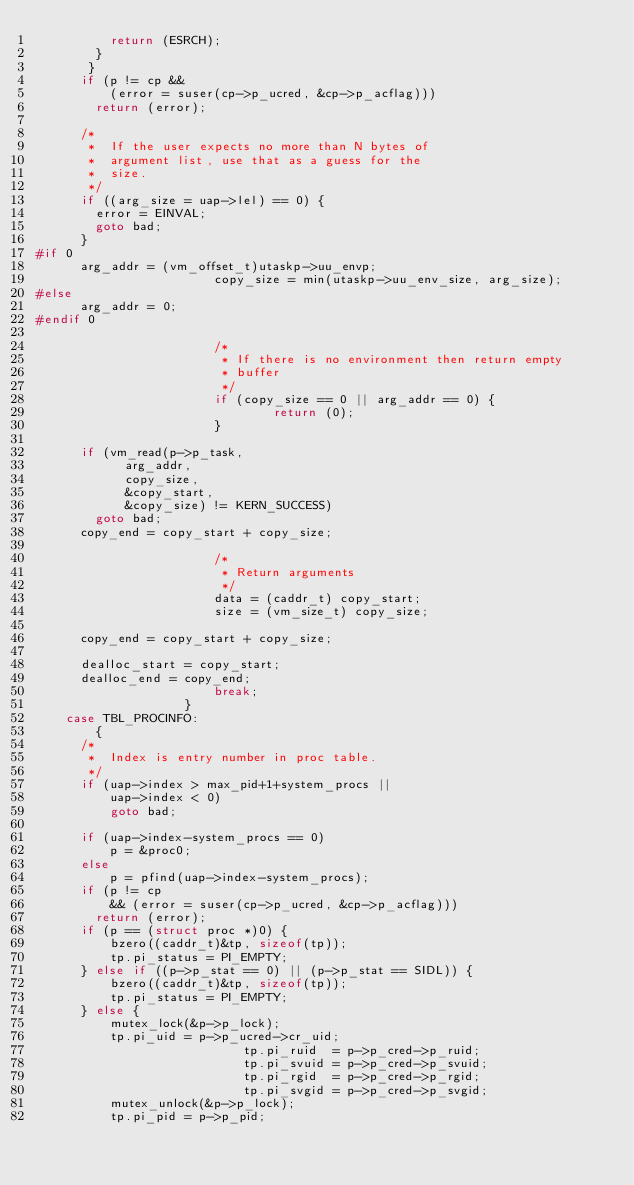<code> <loc_0><loc_0><loc_500><loc_500><_C_>					return (ESRCH);
				}
			 }
			if (p != cp &&
			    (error = suser(cp->p_ucred, &cp->p_acflag)))
				return (error);

			/*
			 *	If the user expects no more than N bytes of
			 *	argument list, use that as a guess for the
			 *	size.
			 */
			if ((arg_size = uap->lel) == 0) {
				error = EINVAL;
				goto bad;
			}
#if 0
			arg_addr = (vm_offset_t)utaskp->uu_envp;
                        copy_size = min(utaskp->uu_env_size, arg_size);
#else
			arg_addr = 0;
#endif 0

                        /*
                         * If there is no environment then return empty
                         * buffer
                         */
                        if (copy_size == 0 || arg_addr == 0) {
                                return (0);
                        }
                        
			if (vm_read(p->p_task,
				    arg_addr,
				    copy_size,
				    &copy_start,
				    &copy_size) != KERN_SUCCESS)
			  goto bad;
			copy_end = copy_start + copy_size;

                        /*
                         * Return arguments
                         */
                        data = (caddr_t) copy_start;
                        size = (vm_size_t) copy_size;
                        
			copy_end = copy_start + copy_size;

			dealloc_start = copy_start;
			dealloc_end = copy_end;
                        break;
                    }
		case TBL_PROCINFO:
		    {
			/*
			 *	Index is entry number in proc table.
			 */
			if (uap->index > max_pid+1+system_procs ||
			    uap->index < 0)
			    goto bad;

			if (uap->index-system_procs == 0)
			    p = &proc0;
			else
			    p = pfind(uap->index-system_procs);
			if (p != cp
			    && (error = suser(cp->p_ucred, &cp->p_acflag)))
				return (error);
			if (p == (struct proc *)0) {
			    bzero((caddr_t)&tp, sizeof(tp));
			    tp.pi_status = PI_EMPTY;
			} else if ((p->p_stat == 0) || (p->p_stat == SIDL)) {
			    bzero((caddr_t)&tp, sizeof(tp));
			    tp.pi_status = PI_EMPTY;
			} else {
			    mutex_lock(&p->p_lock);
			    tp.pi_uid	= p->p_ucred->cr_uid;
                            tp.pi_ruid  = p->p_cred->p_ruid;
                            tp.pi_svuid = p->p_cred->p_svuid;
                            tp.pi_rgid  = p->p_cred->p_rgid;
                            tp.pi_svgid = p->p_cred->p_svgid;
			    mutex_unlock(&p->p_lock);
			    tp.pi_pid	= p->p_pid;</code> 